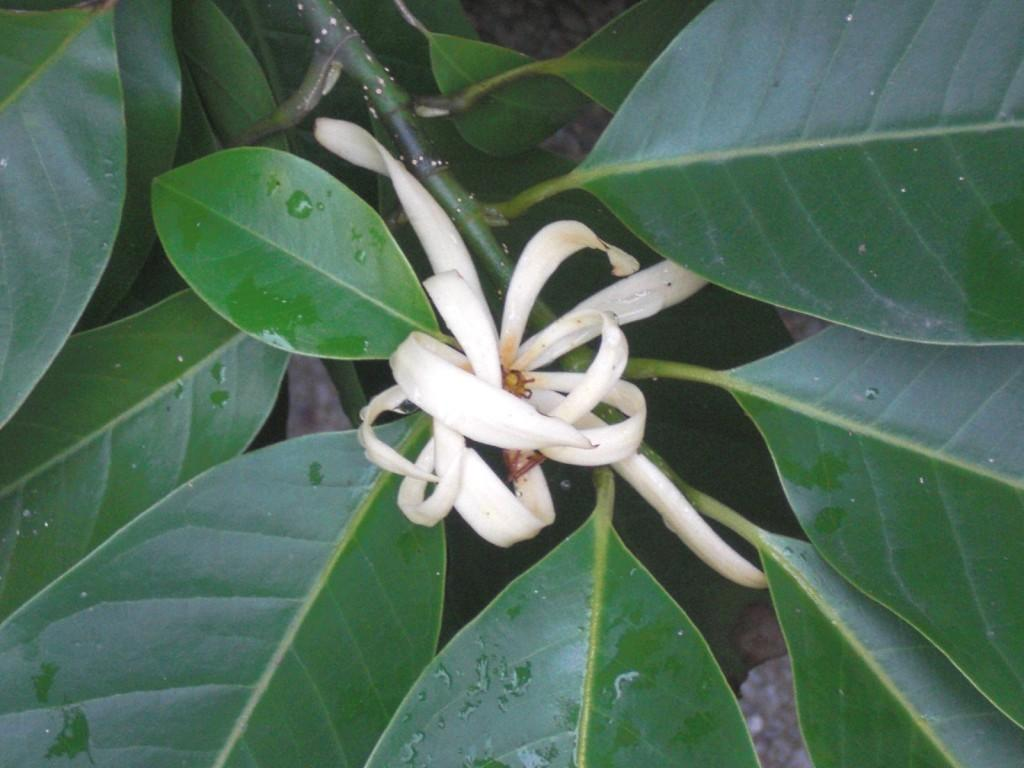What type of plant can be seen in the image? There is a flower in the image. What other parts of the plant are visible in the image? There are leaves in the image. What type of board is being used to hold the tooth in the image? There is no board or tooth present in the image; it only features a flower and leaves. How many nails can be seen holding the flower in the image? There are no nails present in the image; it only features a flower and leaves. 